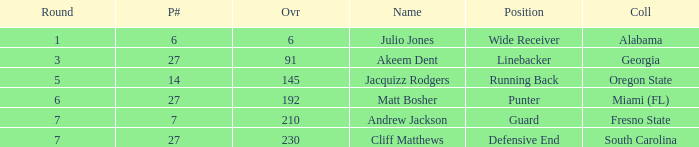Which overall's pick number was 14? 145.0. 